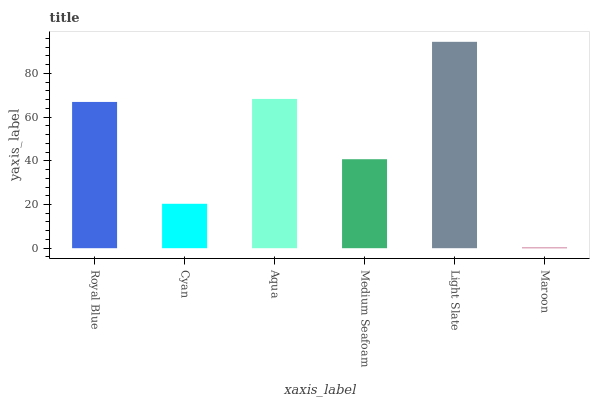Is Maroon the minimum?
Answer yes or no. Yes. Is Light Slate the maximum?
Answer yes or no. Yes. Is Cyan the minimum?
Answer yes or no. No. Is Cyan the maximum?
Answer yes or no. No. Is Royal Blue greater than Cyan?
Answer yes or no. Yes. Is Cyan less than Royal Blue?
Answer yes or no. Yes. Is Cyan greater than Royal Blue?
Answer yes or no. No. Is Royal Blue less than Cyan?
Answer yes or no. No. Is Royal Blue the high median?
Answer yes or no. Yes. Is Medium Seafoam the low median?
Answer yes or no. Yes. Is Light Slate the high median?
Answer yes or no. No. Is Aqua the low median?
Answer yes or no. No. 